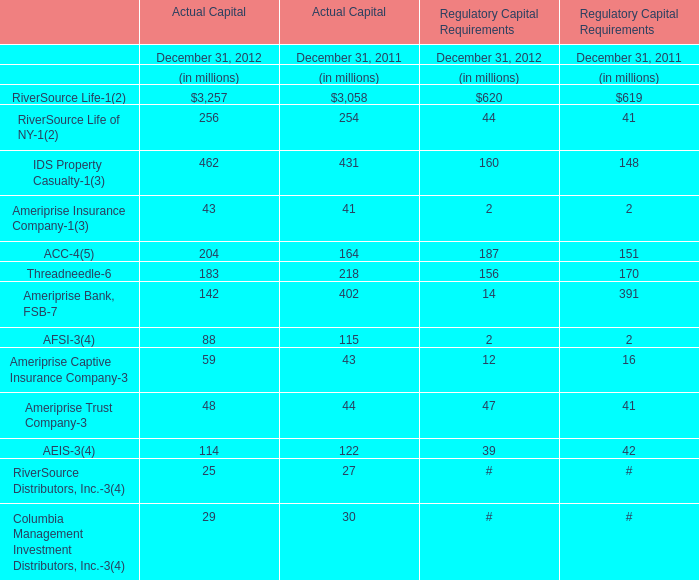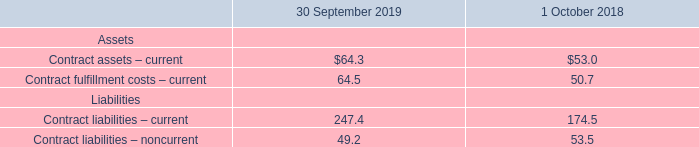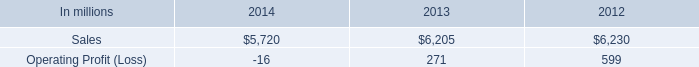If RiverSource Life-1 of Actual Capital develops with the same growth rate in 2012, what will it reach in 2013? (in million) 
Computations: (3257 + ((3257 * (3257 - 3058)) / 3058))
Answer: 3468.94997. 